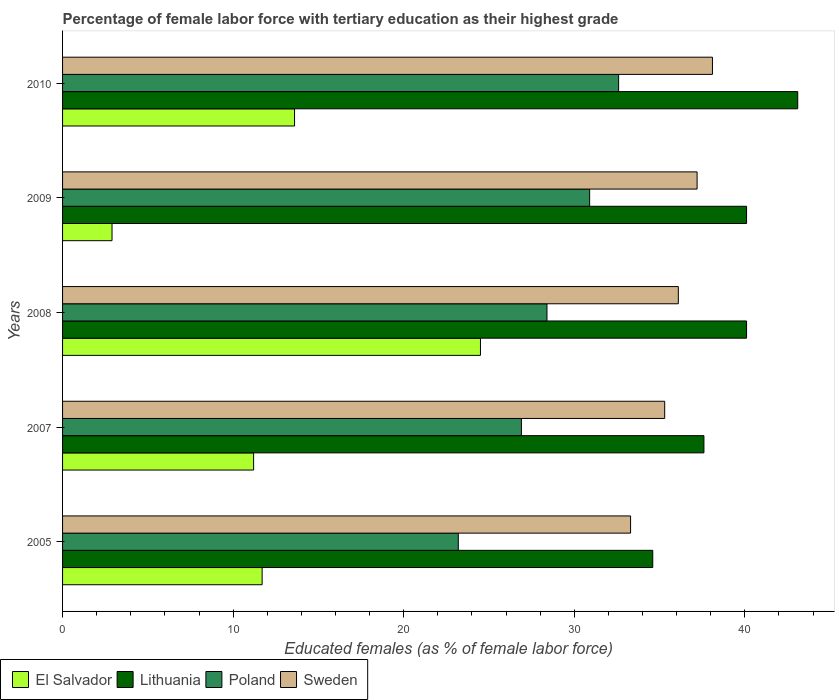How many groups of bars are there?
Give a very brief answer. 5. Are the number of bars on each tick of the Y-axis equal?
Offer a terse response. Yes. How many bars are there on the 3rd tick from the bottom?
Offer a terse response. 4. What is the label of the 1st group of bars from the top?
Offer a terse response. 2010. What is the percentage of female labor force with tertiary education in El Salvador in 2010?
Provide a short and direct response. 13.6. Across all years, what is the maximum percentage of female labor force with tertiary education in Lithuania?
Make the answer very short. 43.1. Across all years, what is the minimum percentage of female labor force with tertiary education in El Salvador?
Offer a very short reply. 2.9. What is the total percentage of female labor force with tertiary education in Sweden in the graph?
Offer a very short reply. 180. What is the difference between the percentage of female labor force with tertiary education in Lithuania in 2008 and that in 2009?
Make the answer very short. 0. What is the difference between the percentage of female labor force with tertiary education in Lithuania in 2010 and the percentage of female labor force with tertiary education in El Salvador in 2009?
Provide a succinct answer. 40.2. What is the average percentage of female labor force with tertiary education in El Salvador per year?
Make the answer very short. 12.78. In the year 2009, what is the difference between the percentage of female labor force with tertiary education in Sweden and percentage of female labor force with tertiary education in El Salvador?
Your response must be concise. 34.3. In how many years, is the percentage of female labor force with tertiary education in Poland greater than 42 %?
Your response must be concise. 0. What is the ratio of the percentage of female labor force with tertiary education in El Salvador in 2005 to that in 2008?
Offer a terse response. 0.48. Is the difference between the percentage of female labor force with tertiary education in Sweden in 2009 and 2010 greater than the difference between the percentage of female labor force with tertiary education in El Salvador in 2009 and 2010?
Your response must be concise. Yes. What is the difference between the highest and the second highest percentage of female labor force with tertiary education in Sweden?
Ensure brevity in your answer.  0.9. What is the difference between the highest and the lowest percentage of female labor force with tertiary education in Lithuania?
Ensure brevity in your answer.  8.5. In how many years, is the percentage of female labor force with tertiary education in Poland greater than the average percentage of female labor force with tertiary education in Poland taken over all years?
Keep it short and to the point. 3. Is the sum of the percentage of female labor force with tertiary education in El Salvador in 2005 and 2007 greater than the maximum percentage of female labor force with tertiary education in Lithuania across all years?
Offer a very short reply. No. What does the 1st bar from the top in 2008 represents?
Your answer should be compact. Sweden. What does the 4th bar from the bottom in 2007 represents?
Keep it short and to the point. Sweden. Is it the case that in every year, the sum of the percentage of female labor force with tertiary education in Sweden and percentage of female labor force with tertiary education in Poland is greater than the percentage of female labor force with tertiary education in El Salvador?
Keep it short and to the point. Yes. Are all the bars in the graph horizontal?
Provide a succinct answer. Yes. What is the difference between two consecutive major ticks on the X-axis?
Provide a succinct answer. 10. Are the values on the major ticks of X-axis written in scientific E-notation?
Offer a terse response. No. How many legend labels are there?
Your answer should be compact. 4. What is the title of the graph?
Ensure brevity in your answer.  Percentage of female labor force with tertiary education as their highest grade. Does "Cuba" appear as one of the legend labels in the graph?
Ensure brevity in your answer.  No. What is the label or title of the X-axis?
Keep it short and to the point. Educated females (as % of female labor force). What is the Educated females (as % of female labor force) in El Salvador in 2005?
Make the answer very short. 11.7. What is the Educated females (as % of female labor force) in Lithuania in 2005?
Provide a short and direct response. 34.6. What is the Educated females (as % of female labor force) in Poland in 2005?
Keep it short and to the point. 23.2. What is the Educated females (as % of female labor force) of Sweden in 2005?
Keep it short and to the point. 33.3. What is the Educated females (as % of female labor force) of El Salvador in 2007?
Provide a short and direct response. 11.2. What is the Educated females (as % of female labor force) of Lithuania in 2007?
Keep it short and to the point. 37.6. What is the Educated females (as % of female labor force) in Poland in 2007?
Keep it short and to the point. 26.9. What is the Educated females (as % of female labor force) of Sweden in 2007?
Keep it short and to the point. 35.3. What is the Educated females (as % of female labor force) in El Salvador in 2008?
Ensure brevity in your answer.  24.5. What is the Educated females (as % of female labor force) of Lithuania in 2008?
Your response must be concise. 40.1. What is the Educated females (as % of female labor force) in Poland in 2008?
Provide a short and direct response. 28.4. What is the Educated females (as % of female labor force) of Sweden in 2008?
Offer a very short reply. 36.1. What is the Educated females (as % of female labor force) in El Salvador in 2009?
Make the answer very short. 2.9. What is the Educated females (as % of female labor force) of Lithuania in 2009?
Keep it short and to the point. 40.1. What is the Educated females (as % of female labor force) of Poland in 2009?
Make the answer very short. 30.9. What is the Educated females (as % of female labor force) of Sweden in 2009?
Offer a terse response. 37.2. What is the Educated females (as % of female labor force) of El Salvador in 2010?
Provide a short and direct response. 13.6. What is the Educated females (as % of female labor force) of Lithuania in 2010?
Provide a short and direct response. 43.1. What is the Educated females (as % of female labor force) of Poland in 2010?
Your answer should be very brief. 32.6. What is the Educated females (as % of female labor force) of Sweden in 2010?
Your answer should be very brief. 38.1. Across all years, what is the maximum Educated females (as % of female labor force) in Lithuania?
Provide a succinct answer. 43.1. Across all years, what is the maximum Educated females (as % of female labor force) in Poland?
Your response must be concise. 32.6. Across all years, what is the maximum Educated females (as % of female labor force) of Sweden?
Your response must be concise. 38.1. Across all years, what is the minimum Educated females (as % of female labor force) of El Salvador?
Ensure brevity in your answer.  2.9. Across all years, what is the minimum Educated females (as % of female labor force) in Lithuania?
Offer a terse response. 34.6. Across all years, what is the minimum Educated females (as % of female labor force) in Poland?
Ensure brevity in your answer.  23.2. Across all years, what is the minimum Educated females (as % of female labor force) in Sweden?
Your answer should be very brief. 33.3. What is the total Educated females (as % of female labor force) of El Salvador in the graph?
Provide a succinct answer. 63.9. What is the total Educated females (as % of female labor force) of Lithuania in the graph?
Make the answer very short. 195.5. What is the total Educated females (as % of female labor force) in Poland in the graph?
Provide a succinct answer. 142. What is the total Educated females (as % of female labor force) in Sweden in the graph?
Provide a succinct answer. 180. What is the difference between the Educated females (as % of female labor force) in El Salvador in 2005 and that in 2007?
Provide a succinct answer. 0.5. What is the difference between the Educated females (as % of female labor force) in Lithuania in 2005 and that in 2007?
Your answer should be very brief. -3. What is the difference between the Educated females (as % of female labor force) of El Salvador in 2005 and that in 2008?
Keep it short and to the point. -12.8. What is the difference between the Educated females (as % of female labor force) in Lithuania in 2005 and that in 2008?
Your answer should be very brief. -5.5. What is the difference between the Educated females (as % of female labor force) in Poland in 2005 and that in 2008?
Give a very brief answer. -5.2. What is the difference between the Educated females (as % of female labor force) in El Salvador in 2005 and that in 2009?
Provide a succinct answer. 8.8. What is the difference between the Educated females (as % of female labor force) of Lithuania in 2005 and that in 2009?
Keep it short and to the point. -5.5. What is the difference between the Educated females (as % of female labor force) of El Salvador in 2005 and that in 2010?
Make the answer very short. -1.9. What is the difference between the Educated females (as % of female labor force) in Poland in 2005 and that in 2010?
Offer a terse response. -9.4. What is the difference between the Educated females (as % of female labor force) in El Salvador in 2007 and that in 2008?
Offer a very short reply. -13.3. What is the difference between the Educated females (as % of female labor force) in Lithuania in 2007 and that in 2008?
Your answer should be compact. -2.5. What is the difference between the Educated females (as % of female labor force) in Poland in 2007 and that in 2008?
Give a very brief answer. -1.5. What is the difference between the Educated females (as % of female labor force) of Poland in 2007 and that in 2009?
Provide a succinct answer. -4. What is the difference between the Educated females (as % of female labor force) of El Salvador in 2007 and that in 2010?
Provide a succinct answer. -2.4. What is the difference between the Educated females (as % of female labor force) in Lithuania in 2007 and that in 2010?
Provide a succinct answer. -5.5. What is the difference between the Educated females (as % of female labor force) in Sweden in 2007 and that in 2010?
Keep it short and to the point. -2.8. What is the difference between the Educated females (as % of female labor force) of El Salvador in 2008 and that in 2009?
Keep it short and to the point. 21.6. What is the difference between the Educated females (as % of female labor force) in Poland in 2008 and that in 2009?
Your answer should be compact. -2.5. What is the difference between the Educated females (as % of female labor force) of Sweden in 2008 and that in 2009?
Keep it short and to the point. -1.1. What is the difference between the Educated females (as % of female labor force) of El Salvador in 2008 and that in 2010?
Your answer should be compact. 10.9. What is the difference between the Educated females (as % of female labor force) in Poland in 2008 and that in 2010?
Give a very brief answer. -4.2. What is the difference between the Educated females (as % of female labor force) of El Salvador in 2009 and that in 2010?
Offer a terse response. -10.7. What is the difference between the Educated females (as % of female labor force) in El Salvador in 2005 and the Educated females (as % of female labor force) in Lithuania in 2007?
Ensure brevity in your answer.  -25.9. What is the difference between the Educated females (as % of female labor force) in El Salvador in 2005 and the Educated females (as % of female labor force) in Poland in 2007?
Your answer should be compact. -15.2. What is the difference between the Educated females (as % of female labor force) of El Salvador in 2005 and the Educated females (as % of female labor force) of Sweden in 2007?
Your answer should be very brief. -23.6. What is the difference between the Educated females (as % of female labor force) in Lithuania in 2005 and the Educated females (as % of female labor force) in Poland in 2007?
Your response must be concise. 7.7. What is the difference between the Educated females (as % of female labor force) in El Salvador in 2005 and the Educated females (as % of female labor force) in Lithuania in 2008?
Your answer should be very brief. -28.4. What is the difference between the Educated females (as % of female labor force) of El Salvador in 2005 and the Educated females (as % of female labor force) of Poland in 2008?
Your answer should be very brief. -16.7. What is the difference between the Educated females (as % of female labor force) in El Salvador in 2005 and the Educated females (as % of female labor force) in Sweden in 2008?
Keep it short and to the point. -24.4. What is the difference between the Educated females (as % of female labor force) of Lithuania in 2005 and the Educated females (as % of female labor force) of Sweden in 2008?
Ensure brevity in your answer.  -1.5. What is the difference between the Educated females (as % of female labor force) of Poland in 2005 and the Educated females (as % of female labor force) of Sweden in 2008?
Offer a very short reply. -12.9. What is the difference between the Educated females (as % of female labor force) of El Salvador in 2005 and the Educated females (as % of female labor force) of Lithuania in 2009?
Provide a succinct answer. -28.4. What is the difference between the Educated females (as % of female labor force) of El Salvador in 2005 and the Educated females (as % of female labor force) of Poland in 2009?
Keep it short and to the point. -19.2. What is the difference between the Educated females (as % of female labor force) in El Salvador in 2005 and the Educated females (as % of female labor force) in Sweden in 2009?
Keep it short and to the point. -25.5. What is the difference between the Educated females (as % of female labor force) of Lithuania in 2005 and the Educated females (as % of female labor force) of Poland in 2009?
Your answer should be very brief. 3.7. What is the difference between the Educated females (as % of female labor force) of Lithuania in 2005 and the Educated females (as % of female labor force) of Sweden in 2009?
Give a very brief answer. -2.6. What is the difference between the Educated females (as % of female labor force) of El Salvador in 2005 and the Educated females (as % of female labor force) of Lithuania in 2010?
Provide a short and direct response. -31.4. What is the difference between the Educated females (as % of female labor force) of El Salvador in 2005 and the Educated females (as % of female labor force) of Poland in 2010?
Give a very brief answer. -20.9. What is the difference between the Educated females (as % of female labor force) of El Salvador in 2005 and the Educated females (as % of female labor force) of Sweden in 2010?
Offer a very short reply. -26.4. What is the difference between the Educated females (as % of female labor force) of Lithuania in 2005 and the Educated females (as % of female labor force) of Sweden in 2010?
Offer a terse response. -3.5. What is the difference between the Educated females (as % of female labor force) in Poland in 2005 and the Educated females (as % of female labor force) in Sweden in 2010?
Your response must be concise. -14.9. What is the difference between the Educated females (as % of female labor force) of El Salvador in 2007 and the Educated females (as % of female labor force) of Lithuania in 2008?
Keep it short and to the point. -28.9. What is the difference between the Educated females (as % of female labor force) of El Salvador in 2007 and the Educated females (as % of female labor force) of Poland in 2008?
Your answer should be compact. -17.2. What is the difference between the Educated females (as % of female labor force) of El Salvador in 2007 and the Educated females (as % of female labor force) of Sweden in 2008?
Make the answer very short. -24.9. What is the difference between the Educated females (as % of female labor force) of Lithuania in 2007 and the Educated females (as % of female labor force) of Poland in 2008?
Your answer should be compact. 9.2. What is the difference between the Educated females (as % of female labor force) of Lithuania in 2007 and the Educated females (as % of female labor force) of Sweden in 2008?
Offer a terse response. 1.5. What is the difference between the Educated females (as % of female labor force) in El Salvador in 2007 and the Educated females (as % of female labor force) in Lithuania in 2009?
Offer a very short reply. -28.9. What is the difference between the Educated females (as % of female labor force) in El Salvador in 2007 and the Educated females (as % of female labor force) in Poland in 2009?
Provide a short and direct response. -19.7. What is the difference between the Educated females (as % of female labor force) of El Salvador in 2007 and the Educated females (as % of female labor force) of Sweden in 2009?
Offer a very short reply. -26. What is the difference between the Educated females (as % of female labor force) in Poland in 2007 and the Educated females (as % of female labor force) in Sweden in 2009?
Ensure brevity in your answer.  -10.3. What is the difference between the Educated females (as % of female labor force) of El Salvador in 2007 and the Educated females (as % of female labor force) of Lithuania in 2010?
Offer a very short reply. -31.9. What is the difference between the Educated females (as % of female labor force) of El Salvador in 2007 and the Educated females (as % of female labor force) of Poland in 2010?
Provide a succinct answer. -21.4. What is the difference between the Educated females (as % of female labor force) in El Salvador in 2007 and the Educated females (as % of female labor force) in Sweden in 2010?
Your answer should be very brief. -26.9. What is the difference between the Educated females (as % of female labor force) in El Salvador in 2008 and the Educated females (as % of female labor force) in Lithuania in 2009?
Make the answer very short. -15.6. What is the difference between the Educated females (as % of female labor force) of El Salvador in 2008 and the Educated females (as % of female labor force) of Poland in 2009?
Offer a terse response. -6.4. What is the difference between the Educated females (as % of female labor force) of El Salvador in 2008 and the Educated females (as % of female labor force) of Sweden in 2009?
Provide a short and direct response. -12.7. What is the difference between the Educated females (as % of female labor force) of Lithuania in 2008 and the Educated females (as % of female labor force) of Poland in 2009?
Provide a succinct answer. 9.2. What is the difference between the Educated females (as % of female labor force) in El Salvador in 2008 and the Educated females (as % of female labor force) in Lithuania in 2010?
Offer a terse response. -18.6. What is the difference between the Educated females (as % of female labor force) in El Salvador in 2008 and the Educated females (as % of female labor force) in Poland in 2010?
Make the answer very short. -8.1. What is the difference between the Educated females (as % of female labor force) in El Salvador in 2008 and the Educated females (as % of female labor force) in Sweden in 2010?
Provide a short and direct response. -13.6. What is the difference between the Educated females (as % of female labor force) in Lithuania in 2008 and the Educated females (as % of female labor force) in Sweden in 2010?
Offer a very short reply. 2. What is the difference between the Educated females (as % of female labor force) of El Salvador in 2009 and the Educated females (as % of female labor force) of Lithuania in 2010?
Offer a very short reply. -40.2. What is the difference between the Educated females (as % of female labor force) of El Salvador in 2009 and the Educated females (as % of female labor force) of Poland in 2010?
Your answer should be compact. -29.7. What is the difference between the Educated females (as % of female labor force) of El Salvador in 2009 and the Educated females (as % of female labor force) of Sweden in 2010?
Ensure brevity in your answer.  -35.2. What is the difference between the Educated females (as % of female labor force) in Lithuania in 2009 and the Educated females (as % of female labor force) in Poland in 2010?
Your answer should be very brief. 7.5. What is the average Educated females (as % of female labor force) of El Salvador per year?
Make the answer very short. 12.78. What is the average Educated females (as % of female labor force) of Lithuania per year?
Keep it short and to the point. 39.1. What is the average Educated females (as % of female labor force) in Poland per year?
Ensure brevity in your answer.  28.4. In the year 2005, what is the difference between the Educated females (as % of female labor force) of El Salvador and Educated females (as % of female labor force) of Lithuania?
Give a very brief answer. -22.9. In the year 2005, what is the difference between the Educated females (as % of female labor force) in El Salvador and Educated females (as % of female labor force) in Poland?
Give a very brief answer. -11.5. In the year 2005, what is the difference between the Educated females (as % of female labor force) of El Salvador and Educated females (as % of female labor force) of Sweden?
Your answer should be very brief. -21.6. In the year 2007, what is the difference between the Educated females (as % of female labor force) of El Salvador and Educated females (as % of female labor force) of Lithuania?
Your response must be concise. -26.4. In the year 2007, what is the difference between the Educated females (as % of female labor force) of El Salvador and Educated females (as % of female labor force) of Poland?
Keep it short and to the point. -15.7. In the year 2007, what is the difference between the Educated females (as % of female labor force) of El Salvador and Educated females (as % of female labor force) of Sweden?
Ensure brevity in your answer.  -24.1. In the year 2007, what is the difference between the Educated females (as % of female labor force) in Lithuania and Educated females (as % of female labor force) in Sweden?
Ensure brevity in your answer.  2.3. In the year 2008, what is the difference between the Educated females (as % of female labor force) of El Salvador and Educated females (as % of female labor force) of Lithuania?
Ensure brevity in your answer.  -15.6. In the year 2008, what is the difference between the Educated females (as % of female labor force) of El Salvador and Educated females (as % of female labor force) of Poland?
Your answer should be compact. -3.9. In the year 2008, what is the difference between the Educated females (as % of female labor force) of El Salvador and Educated females (as % of female labor force) of Sweden?
Your answer should be compact. -11.6. In the year 2008, what is the difference between the Educated females (as % of female labor force) in Lithuania and Educated females (as % of female labor force) in Poland?
Give a very brief answer. 11.7. In the year 2008, what is the difference between the Educated females (as % of female labor force) of Poland and Educated females (as % of female labor force) of Sweden?
Keep it short and to the point. -7.7. In the year 2009, what is the difference between the Educated females (as % of female labor force) in El Salvador and Educated females (as % of female labor force) in Lithuania?
Give a very brief answer. -37.2. In the year 2009, what is the difference between the Educated females (as % of female labor force) of El Salvador and Educated females (as % of female labor force) of Poland?
Give a very brief answer. -28. In the year 2009, what is the difference between the Educated females (as % of female labor force) of El Salvador and Educated females (as % of female labor force) of Sweden?
Your response must be concise. -34.3. In the year 2009, what is the difference between the Educated females (as % of female labor force) in Lithuania and Educated females (as % of female labor force) in Sweden?
Keep it short and to the point. 2.9. In the year 2010, what is the difference between the Educated females (as % of female labor force) of El Salvador and Educated females (as % of female labor force) of Lithuania?
Give a very brief answer. -29.5. In the year 2010, what is the difference between the Educated females (as % of female labor force) of El Salvador and Educated females (as % of female labor force) of Sweden?
Provide a short and direct response. -24.5. In the year 2010, what is the difference between the Educated females (as % of female labor force) of Lithuania and Educated females (as % of female labor force) of Poland?
Keep it short and to the point. 10.5. In the year 2010, what is the difference between the Educated females (as % of female labor force) in Lithuania and Educated females (as % of female labor force) in Sweden?
Your answer should be very brief. 5. What is the ratio of the Educated females (as % of female labor force) of El Salvador in 2005 to that in 2007?
Give a very brief answer. 1.04. What is the ratio of the Educated females (as % of female labor force) in Lithuania in 2005 to that in 2007?
Your response must be concise. 0.92. What is the ratio of the Educated females (as % of female labor force) of Poland in 2005 to that in 2007?
Make the answer very short. 0.86. What is the ratio of the Educated females (as % of female labor force) of Sweden in 2005 to that in 2007?
Offer a terse response. 0.94. What is the ratio of the Educated females (as % of female labor force) in El Salvador in 2005 to that in 2008?
Provide a short and direct response. 0.48. What is the ratio of the Educated females (as % of female labor force) of Lithuania in 2005 to that in 2008?
Provide a succinct answer. 0.86. What is the ratio of the Educated females (as % of female labor force) of Poland in 2005 to that in 2008?
Your answer should be very brief. 0.82. What is the ratio of the Educated females (as % of female labor force) in Sweden in 2005 to that in 2008?
Your response must be concise. 0.92. What is the ratio of the Educated females (as % of female labor force) of El Salvador in 2005 to that in 2009?
Provide a succinct answer. 4.03. What is the ratio of the Educated females (as % of female labor force) in Lithuania in 2005 to that in 2009?
Provide a short and direct response. 0.86. What is the ratio of the Educated females (as % of female labor force) of Poland in 2005 to that in 2009?
Provide a short and direct response. 0.75. What is the ratio of the Educated females (as % of female labor force) of Sweden in 2005 to that in 2009?
Give a very brief answer. 0.9. What is the ratio of the Educated females (as % of female labor force) in El Salvador in 2005 to that in 2010?
Give a very brief answer. 0.86. What is the ratio of the Educated females (as % of female labor force) of Lithuania in 2005 to that in 2010?
Give a very brief answer. 0.8. What is the ratio of the Educated females (as % of female labor force) of Poland in 2005 to that in 2010?
Your response must be concise. 0.71. What is the ratio of the Educated females (as % of female labor force) in Sweden in 2005 to that in 2010?
Keep it short and to the point. 0.87. What is the ratio of the Educated females (as % of female labor force) in El Salvador in 2007 to that in 2008?
Provide a succinct answer. 0.46. What is the ratio of the Educated females (as % of female labor force) of Lithuania in 2007 to that in 2008?
Your response must be concise. 0.94. What is the ratio of the Educated females (as % of female labor force) of Poland in 2007 to that in 2008?
Provide a succinct answer. 0.95. What is the ratio of the Educated females (as % of female labor force) of Sweden in 2007 to that in 2008?
Provide a short and direct response. 0.98. What is the ratio of the Educated females (as % of female labor force) in El Salvador in 2007 to that in 2009?
Provide a short and direct response. 3.86. What is the ratio of the Educated females (as % of female labor force) in Lithuania in 2007 to that in 2009?
Your response must be concise. 0.94. What is the ratio of the Educated females (as % of female labor force) in Poland in 2007 to that in 2009?
Provide a short and direct response. 0.87. What is the ratio of the Educated females (as % of female labor force) of Sweden in 2007 to that in 2009?
Provide a short and direct response. 0.95. What is the ratio of the Educated females (as % of female labor force) in El Salvador in 2007 to that in 2010?
Keep it short and to the point. 0.82. What is the ratio of the Educated females (as % of female labor force) of Lithuania in 2007 to that in 2010?
Offer a very short reply. 0.87. What is the ratio of the Educated females (as % of female labor force) of Poland in 2007 to that in 2010?
Make the answer very short. 0.83. What is the ratio of the Educated females (as % of female labor force) of Sweden in 2007 to that in 2010?
Your response must be concise. 0.93. What is the ratio of the Educated females (as % of female labor force) in El Salvador in 2008 to that in 2009?
Provide a succinct answer. 8.45. What is the ratio of the Educated females (as % of female labor force) of Lithuania in 2008 to that in 2009?
Make the answer very short. 1. What is the ratio of the Educated females (as % of female labor force) in Poland in 2008 to that in 2009?
Your answer should be compact. 0.92. What is the ratio of the Educated females (as % of female labor force) in Sweden in 2008 to that in 2009?
Keep it short and to the point. 0.97. What is the ratio of the Educated females (as % of female labor force) in El Salvador in 2008 to that in 2010?
Offer a terse response. 1.8. What is the ratio of the Educated females (as % of female labor force) of Lithuania in 2008 to that in 2010?
Offer a terse response. 0.93. What is the ratio of the Educated females (as % of female labor force) in Poland in 2008 to that in 2010?
Provide a succinct answer. 0.87. What is the ratio of the Educated females (as % of female labor force) in Sweden in 2008 to that in 2010?
Your response must be concise. 0.95. What is the ratio of the Educated females (as % of female labor force) in El Salvador in 2009 to that in 2010?
Your answer should be compact. 0.21. What is the ratio of the Educated females (as % of female labor force) of Lithuania in 2009 to that in 2010?
Make the answer very short. 0.93. What is the ratio of the Educated females (as % of female labor force) in Poland in 2009 to that in 2010?
Provide a short and direct response. 0.95. What is the ratio of the Educated females (as % of female labor force) in Sweden in 2009 to that in 2010?
Offer a terse response. 0.98. What is the difference between the highest and the second highest Educated females (as % of female labor force) of Sweden?
Make the answer very short. 0.9. What is the difference between the highest and the lowest Educated females (as % of female labor force) in El Salvador?
Keep it short and to the point. 21.6. What is the difference between the highest and the lowest Educated females (as % of female labor force) in Lithuania?
Offer a terse response. 8.5. What is the difference between the highest and the lowest Educated females (as % of female labor force) in Sweden?
Your response must be concise. 4.8. 